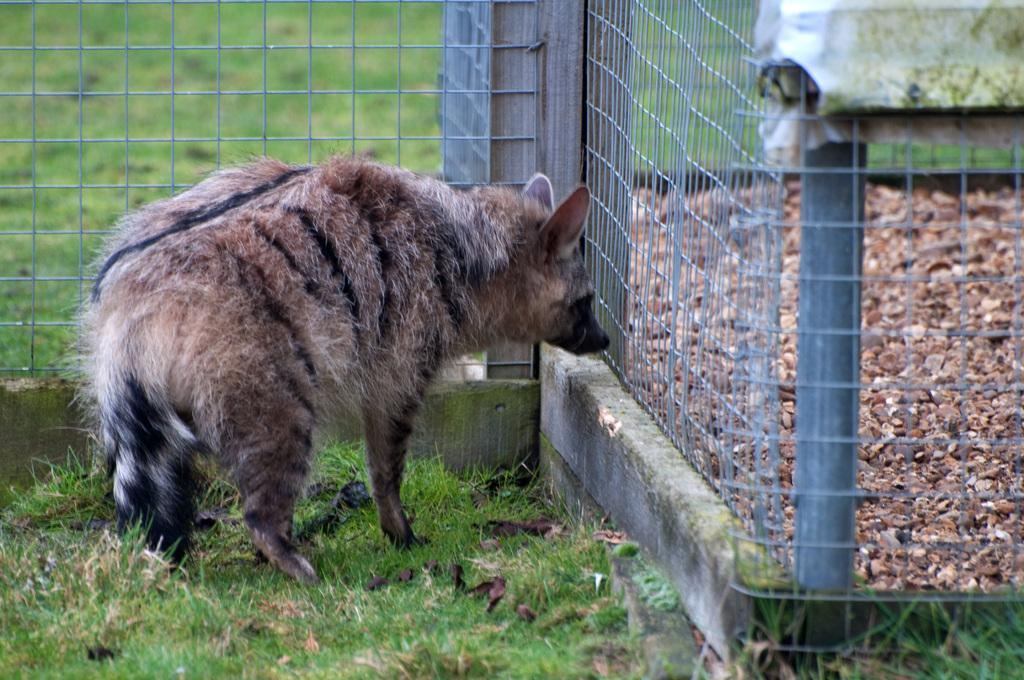What is the main subject in the center of the image? There is an animal in the center of the image. What can be seen in the background of the image? There is a fence in the background of the image. What type of vegetation covers the ground in the image? The ground is covered with grass at the bottom of the image. How many chairs are visible on the page in the image? There are no chairs or pages present in the image; it features an animal and a fence in a grassy setting. 